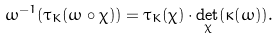Convert formula to latex. <formula><loc_0><loc_0><loc_500><loc_500>\omega ^ { - 1 } ( \tau _ { K } ( \omega \circ \chi ) ) = \tau _ { K } ( \chi ) \cdot \det _ { \chi } ( \kappa ( \omega ) ) .</formula> 